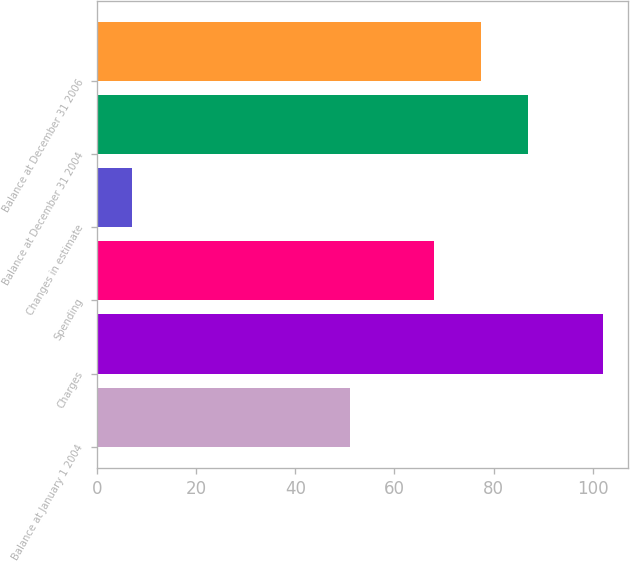Convert chart to OTSL. <chart><loc_0><loc_0><loc_500><loc_500><bar_chart><fcel>Balance at January 1 2004<fcel>Charges<fcel>Spending<fcel>Changes in estimate<fcel>Balance at December 31 2004<fcel>Balance at December 31 2006<nl><fcel>51<fcel>102<fcel>68<fcel>7<fcel>87<fcel>77.5<nl></chart> 